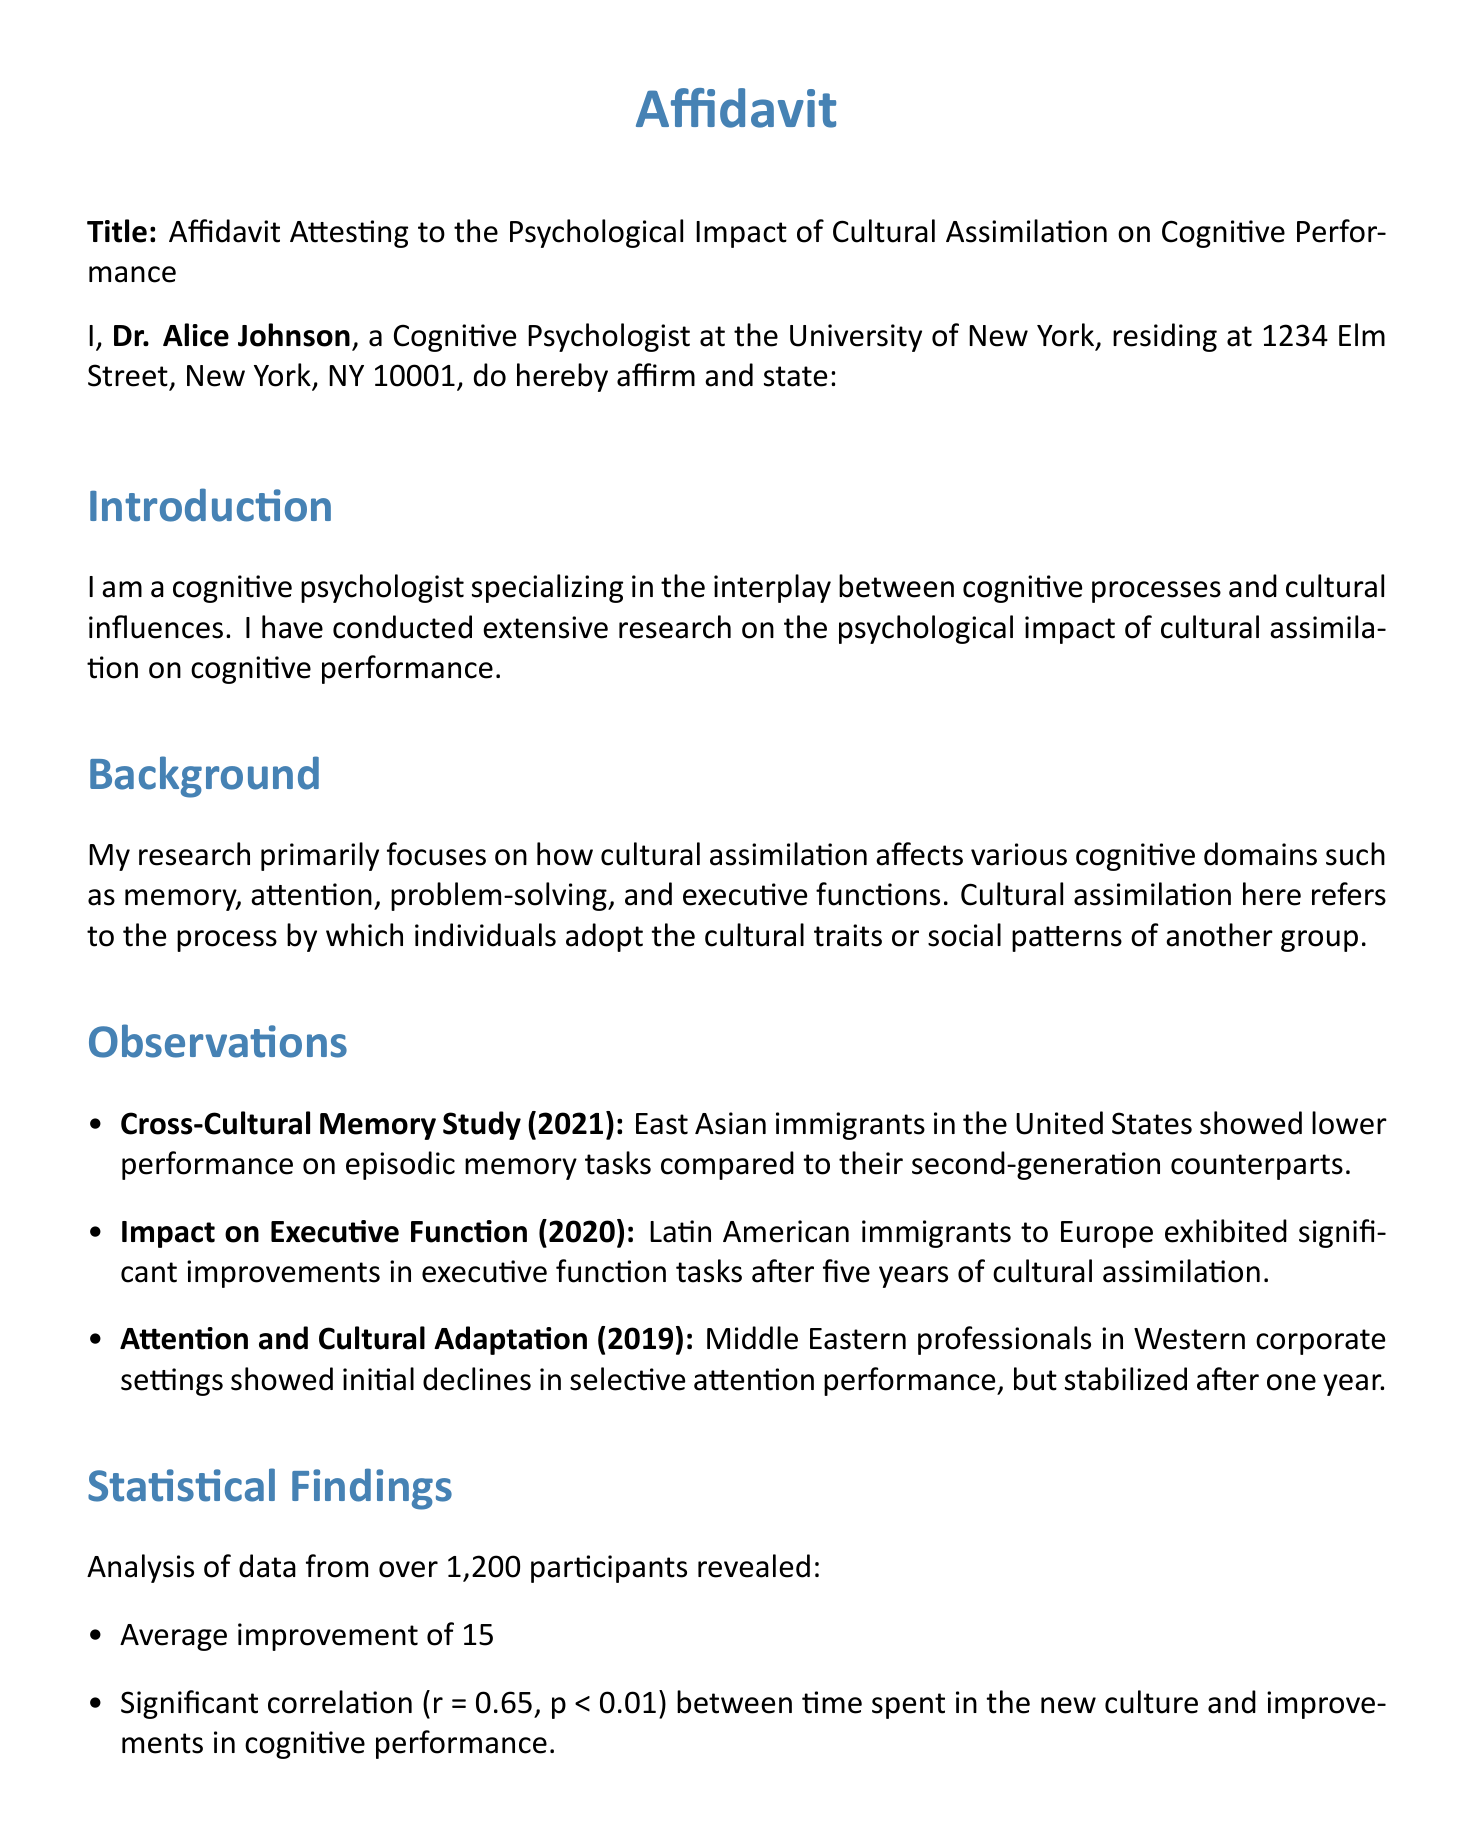What is the name of the affiant? The affiant is the individual who has signed the affidavit, which is Dr. Alice Johnson.
Answer: Dr. Alice Johnson What is the date of the affidavit? The date on which the affidavit was signed is stated in the document as October 2, 2023.
Answer: October 2, 2023 What is the primary focus of Dr. Johnson's research? The primary focus of Dr. Johnson's research is on how cultural assimilation affects various cognitive domains.
Answer: Cultural assimilation and cognitive performance How many participants were involved in the statistical analysis? The statistical analysis mentioned in the document involved a total of over 1,200 participants.
Answer: Over 1,200 participants What average percentage improvement was reported in executive functions? The document states an average improvement of 15% in executive functions for culturally assimilated individuals.
Answer: 15% What correlation coefficient is reported in the findings? A significant correlation of r = 0.65 is reported in the statistical findings of the document.
Answer: r = 0.65 What year was the study on executive function conducted? The study focusing on the impact on executive function was conducted in the year 2020.
Answer: 2020 What is the location of Dr. Johnson's residence? The affidavit states that Dr. Johnson resides at 1234 Elm Street, New York, NY 10001.
Answer: 1234 Elm Street, New York, NY 10001 What is the response time taken for attention performance to stabilize in the Middle Eastern professionals study? The document mentions that attention performance stabilized after one year for Middle Eastern professionals.
Answer: One year 